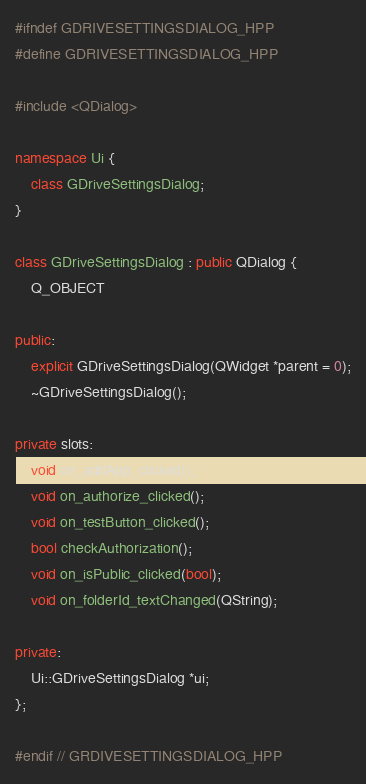<code> <loc_0><loc_0><loc_500><loc_500><_C++_>#ifndef GDRIVESETTINGSDIALOG_HPP
#define GDRIVESETTINGSDIALOG_HPP

#include <QDialog>

namespace Ui {
    class GDriveSettingsDialog;
}

class GDriveSettingsDialog : public QDialog {
    Q_OBJECT

public:
    explicit GDriveSettingsDialog(QWidget *parent = 0);
    ~GDriveSettingsDialog();

private slots:
    void on_addApp_clicked();
    void on_authorize_clicked();
    void on_testButton_clicked();
    bool checkAuthorization();
    void on_isPublic_clicked(bool);
    void on_folderId_textChanged(QString);

private:
    Ui::GDriveSettingsDialog *ui;
};

#endif // GRDIVESETTINGSDIALOG_HPP
</code> 